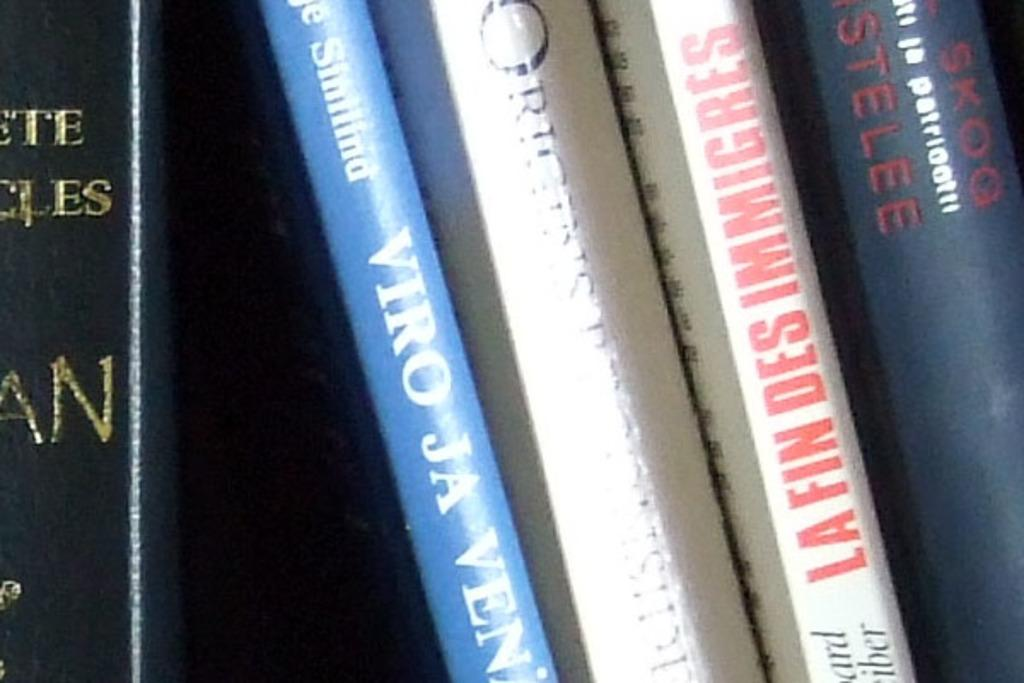<image>
Offer a succinct explanation of the picture presented. A collection of books includes the title LA FIN DES IMMIGRES. 